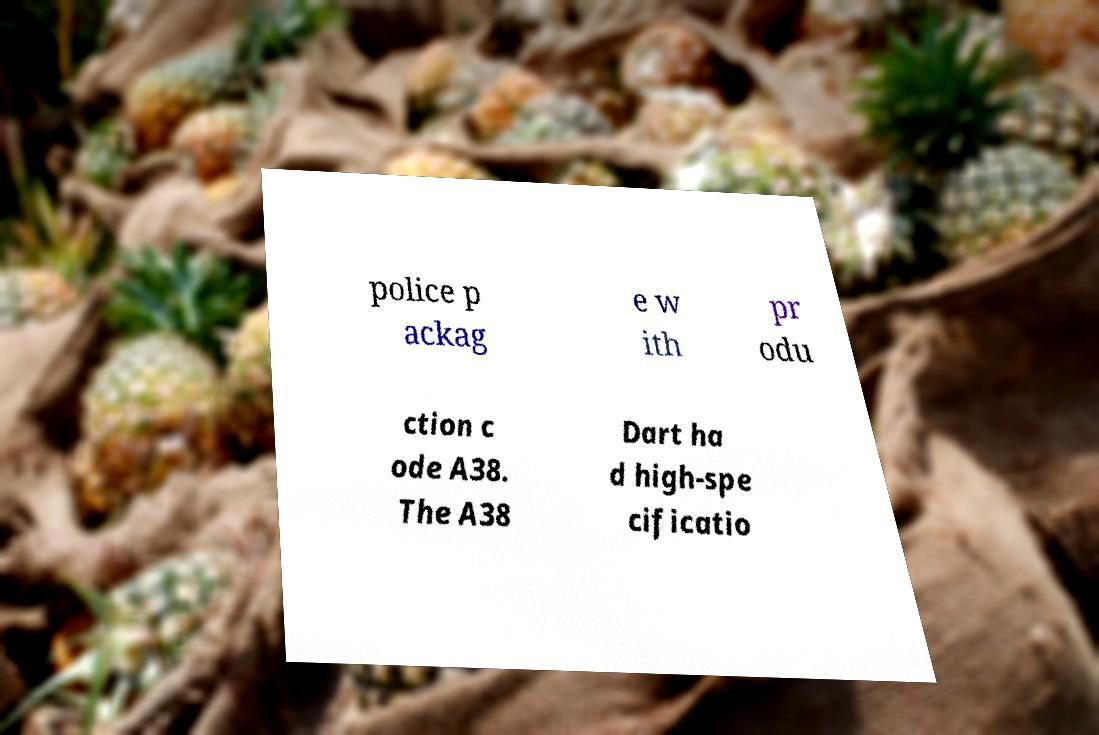Please read and relay the text visible in this image. What does it say? police p ackag e w ith pr odu ction c ode A38. The A38 Dart ha d high-spe cificatio 